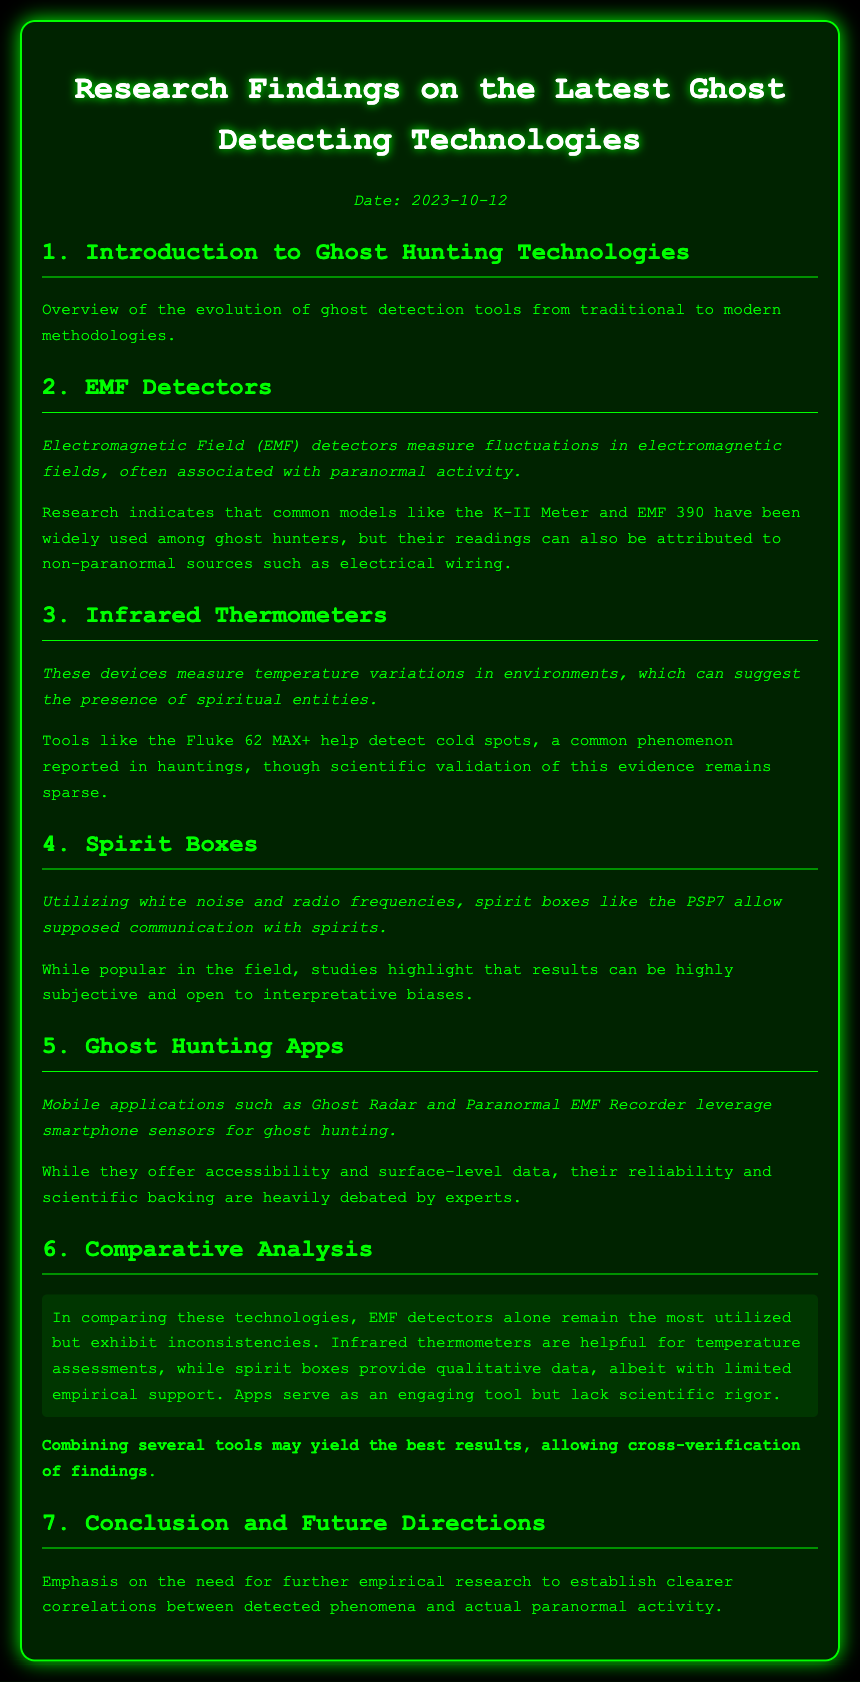What is the date of the research findings? The document specifies the date at the beginning, which is included within a paragraph.
Answer: 2023-10-12 What type of device do EMF detectors measure? The description explains that EMF detectors measure electromagnetic fields, associated with paranormal activities.
Answer: Electromagnetic Field Which tool is mentioned as measuring temperature variations? The document identifies infrared thermometers as the devices measuring temperature variations in environments.
Answer: Infrared Thermometers What is a concern regarding spirit boxes? The effectiveness section highlights a specific concern about the results being subjective and open to biases.
Answer: Subjective Which ghost hunting tools are specifically mentioned as mobile applications? The document lists specific mobile applications as examples of ghost hunting tools in the section.
Answer: Ghost Radar and Paranormal EMF Recorder What is a key finding in the comparative analysis? The summary provides insight into the effectiveness of different technologies and their utilizations and inconsistencies.
Answer: EMF detectors remain the most utilized but exhibit inconsistencies What does the document emphasize regarding future research? The conclusion states a specific need regarding empirical research to establish correlations.
Answer: Need for further empirical research Which devices allow supposed communication with spirits? The document describes spirit boxes as devices that utilize white noise and radio frequencies for this purpose.
Answer: Spirit Boxes 